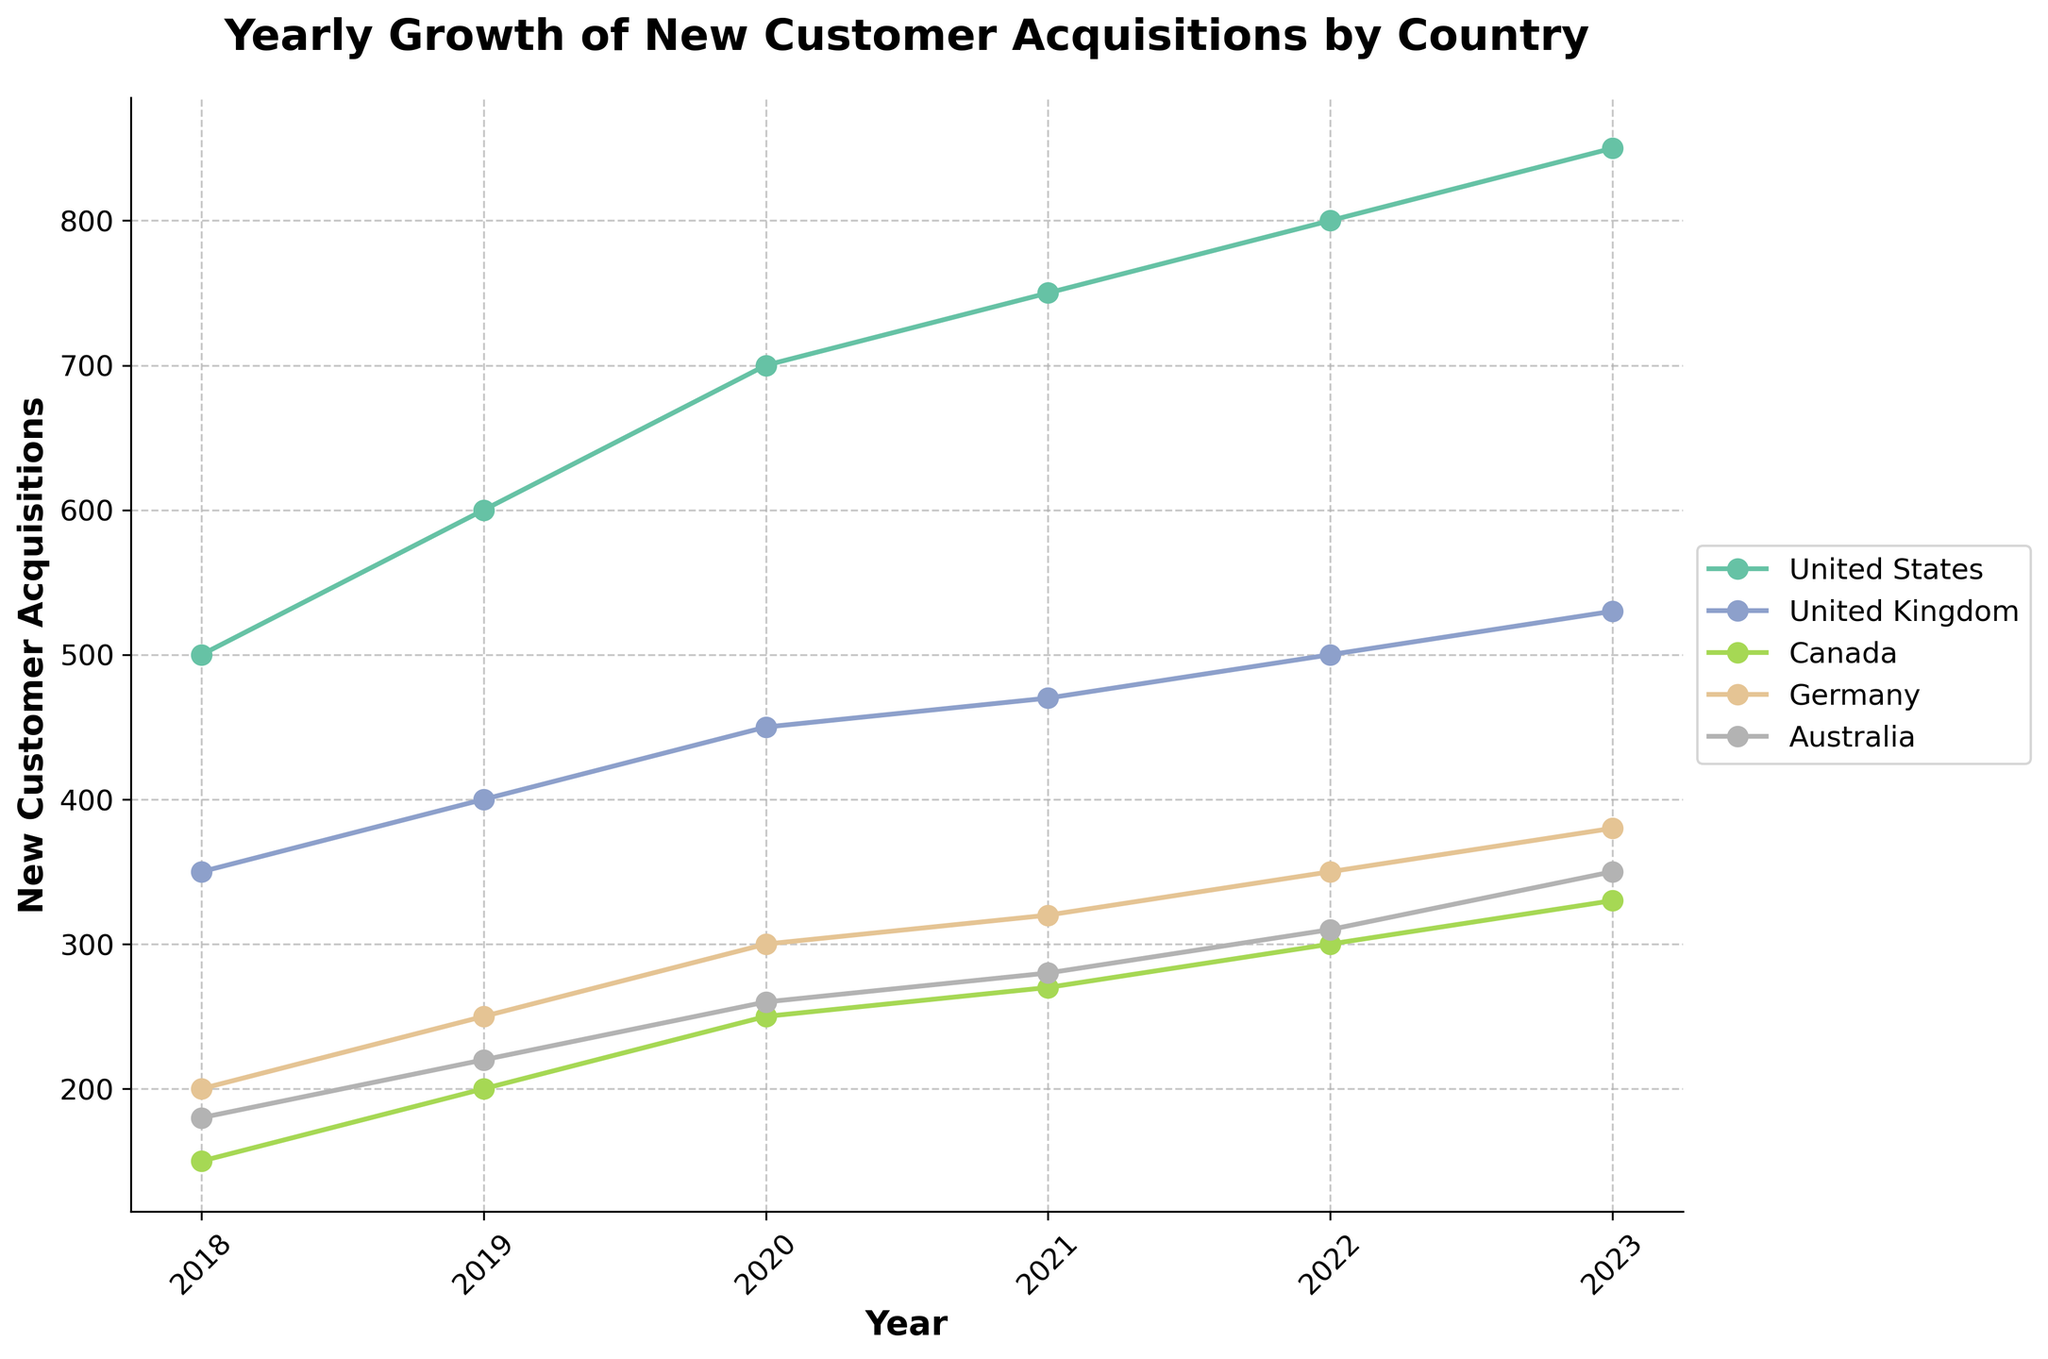What is the title of the figure? The title is at the top of the figure and reads: "Yearly Growth of New Customer Acquisitions by Country."
Answer: Yearly Growth of New Customer Acquisitions by Country Which country had the highest number of new customer acquisitions in 2023? By observing the figure, the United States had the highest number of new customer acquisitions in 2023.
Answer: United States What is the overall trend of new customer acquisitions for Canada from 2018 to 2023? The trend line for Canada shows a consistent increase in new customer acquisitions from 2018 to 2023.
Answer: Increasing How many years are displayed on the x-axis? The figure has data points for each year from 2018 to 2023, which means 6 years are displayed on the x-axis.
Answer: 6 Compare the growth in new customer acquisitions between the United States and Germany from 2018 to 2023. Which country had a larger increase? In 2018, the United States had 500 and Germany had 200 acquisitions. By 2023, the United States had 850 and Germany had 380 acquisitions. The United States increased by 350 (850 - 500), and Germany increased by 180 (380 - 200). The United States had a larger increase.
Answer: United States What was the number of new customer acquisitions for Australia in 2021? We can find the data point for Australia in 2021 directly on the figure. Australia had 280 new customer acquisitions in 2021.
Answer: 280 Which country had the least growth in new customer acquisitions between 2018 and 2023? By comparing the growth of all countries through the lines on the plot, Canada had the least growth, going from 150 in 2018 to 330 in 2023, an increase of 180.
Answer: Canada For which years did the United Kingdom surpass 400 new customer acquisitions? Observing the United Kingdom's data points, the country surpassed 400 new customer acquisitions in 2019, 2020, 2021, 2022, and 2023.
Answer: 2019-2023 What is the growth rate of customer acquisitions for Australia from 2018 to 2023? In 2018, Australia had 180 acquisitions, and in 2023, it had 350. The growth rate over these years is (350 - 180) / 180 = 0.944, or 94.4%.
Answer: 94.4% Which country had the most consistent yearly growth in new customer acquisitions? By examining the evenness of the growth lines, the United States shows the most consistent yearly growth without major fluctuations.
Answer: United States 